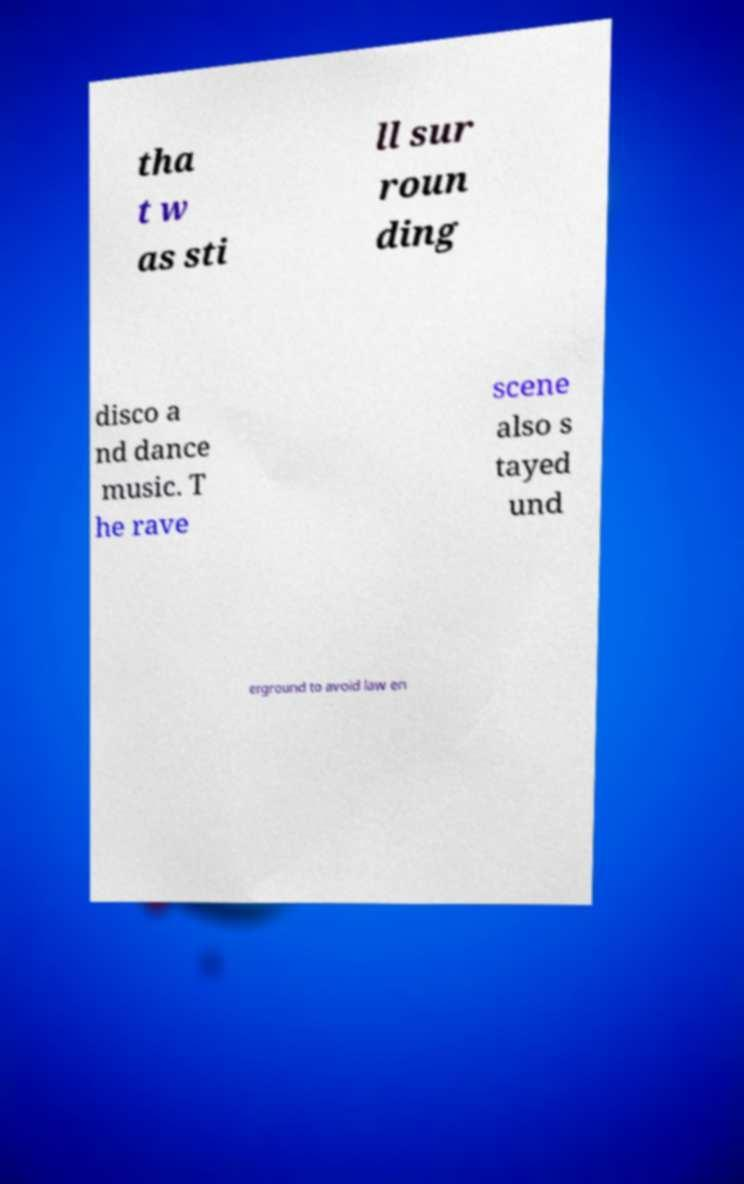What messages or text are displayed in this image? I need them in a readable, typed format. tha t w as sti ll sur roun ding disco a nd dance music. T he rave scene also s tayed und erground to avoid law en 